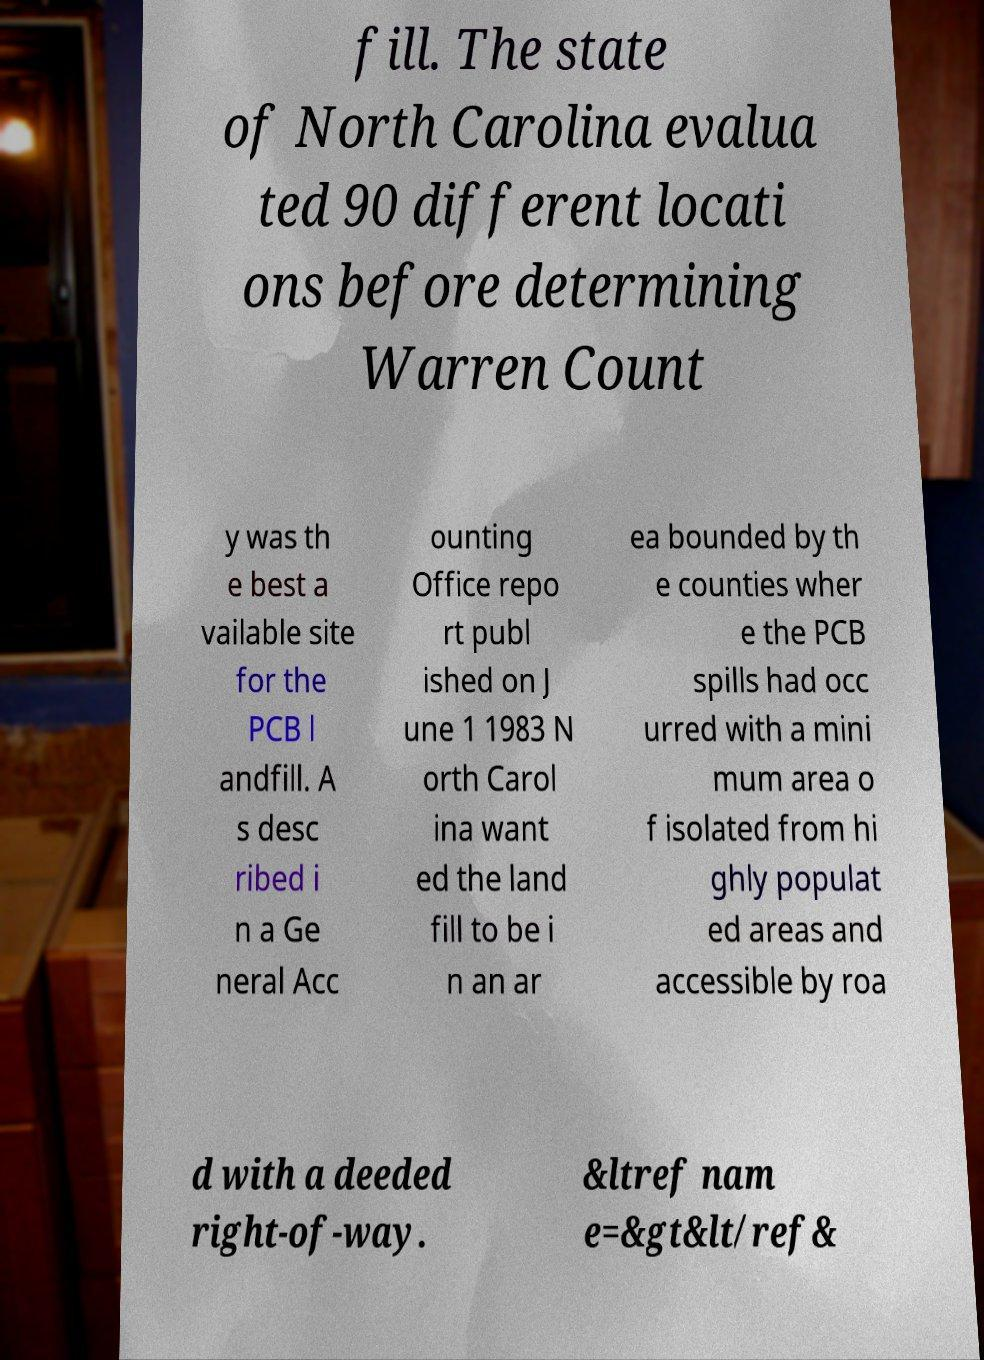Can you accurately transcribe the text from the provided image for me? fill. The state of North Carolina evalua ted 90 different locati ons before determining Warren Count y was th e best a vailable site for the PCB l andfill. A s desc ribed i n a Ge neral Acc ounting Office repo rt publ ished on J une 1 1983 N orth Carol ina want ed the land fill to be i n an ar ea bounded by th e counties wher e the PCB spills had occ urred with a mini mum area o f isolated from hi ghly populat ed areas and accessible by roa d with a deeded right-of-way. &ltref nam e=&gt&lt/ref& 